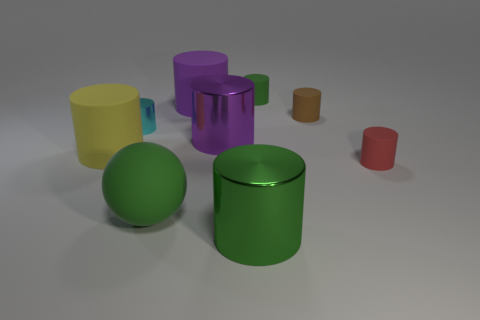Are there any patterns or consistencies in the colors of the objects? Indeed, the objects display a variety of solid colors, and there is a pattern in the way colors are assigned: each object has a unique color, suggesting a deliberate choice to represent diversity or categorization. Could the colors represent anything specific? It's possible the colors could be used to represent different categories or to aid in quick identification in a functional setting, such as in a sorting system or educational tool. 